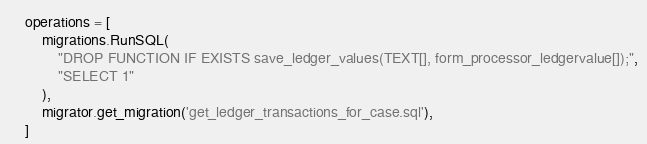<code> <loc_0><loc_0><loc_500><loc_500><_Python_>
    operations = [
        migrations.RunSQL(
            "DROP FUNCTION IF EXISTS save_ledger_values(TEXT[], form_processor_ledgervalue[]);",
            "SELECT 1"
        ),
        migrator.get_migration('get_ledger_transactions_for_case.sql'),
    ]
</code> 